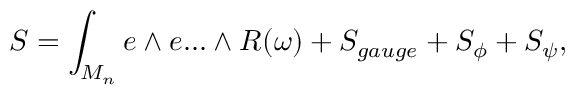<formula> <loc_0><loc_0><loc_500><loc_500>S = \int _ { M _ { n } } e \wedge e \dots \wedge R ( \omega ) + S _ { g a u g e } + S _ { \phi } + S _ { \psi } ,</formula> 